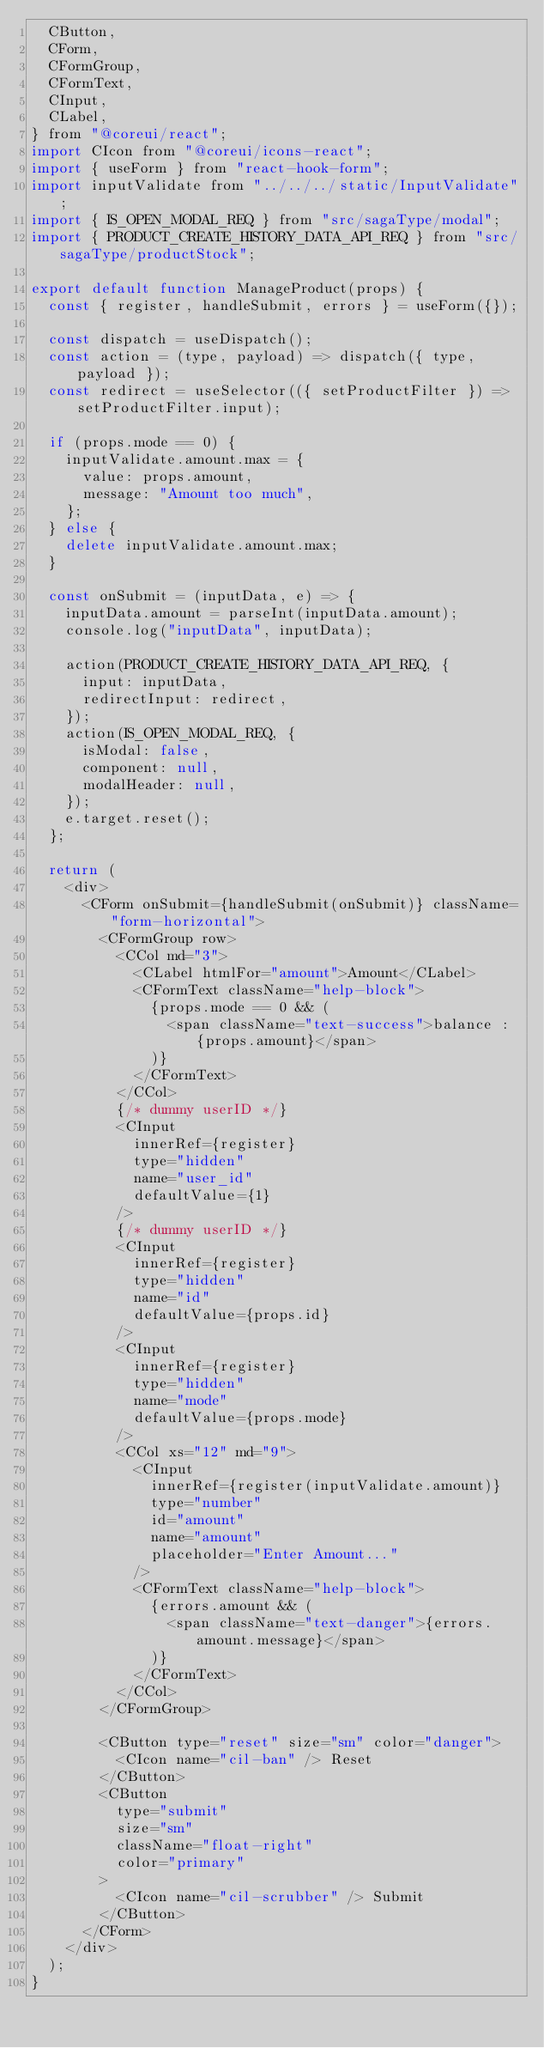<code> <loc_0><loc_0><loc_500><loc_500><_JavaScript_>  CButton,
  CForm,
  CFormGroup,
  CFormText,
  CInput,
  CLabel,
} from "@coreui/react";
import CIcon from "@coreui/icons-react";
import { useForm } from "react-hook-form";
import inputValidate from "../../../static/InputValidate";
import { IS_OPEN_MODAL_REQ } from "src/sagaType/modal";
import { PRODUCT_CREATE_HISTORY_DATA_API_REQ } from "src/sagaType/productStock";

export default function ManageProduct(props) {
  const { register, handleSubmit, errors } = useForm({});

  const dispatch = useDispatch();
  const action = (type, payload) => dispatch({ type, payload });
  const redirect = useSelector(({ setProductFilter }) => setProductFilter.input);

  if (props.mode == 0) {
    inputValidate.amount.max = {
      value: props.amount,
      message: "Amount too much",
    };
  } else {
    delete inputValidate.amount.max;
  }

  const onSubmit = (inputData, e) => {
    inputData.amount = parseInt(inputData.amount);
    console.log("inputData", inputData);

    action(PRODUCT_CREATE_HISTORY_DATA_API_REQ, {
      input: inputData,
      redirectInput: redirect,
    });
    action(IS_OPEN_MODAL_REQ, {
      isModal: false,
      component: null,
      modalHeader: null,
    });
    e.target.reset();
  };

  return (
    <div>
      <CForm onSubmit={handleSubmit(onSubmit)} className="form-horizontal">
        <CFormGroup row>
          <CCol md="3">
            <CLabel htmlFor="amount">Amount</CLabel>
            <CFormText className="help-block">
              {props.mode == 0 && (
                <span className="text-success">balance : {props.amount}</span>
              )}
            </CFormText>
          </CCol>
          {/* dummy userID */}
          <CInput
            innerRef={register}
            type="hidden"
            name="user_id"
            defaultValue={1}
          />
          {/* dummy userID */}
          <CInput
            innerRef={register}
            type="hidden"
            name="id"
            defaultValue={props.id}
          />
          <CInput
            innerRef={register}
            type="hidden"
            name="mode"
            defaultValue={props.mode}
          />
          <CCol xs="12" md="9">
            <CInput
              innerRef={register(inputValidate.amount)}
              type="number"
              id="amount"
              name="amount"
              placeholder="Enter Amount..."
            />
            <CFormText className="help-block">
              {errors.amount && (
                <span className="text-danger">{errors.amount.message}</span>
              )}
            </CFormText>
          </CCol>
        </CFormGroup>

        <CButton type="reset" size="sm" color="danger">
          <CIcon name="cil-ban" /> Reset
        </CButton>
        <CButton
          type="submit"
          size="sm"
          className="float-right"
          color="primary"
        >
          <CIcon name="cil-scrubber" /> Submit
        </CButton>
      </CForm>
    </div>
  );
}
</code> 